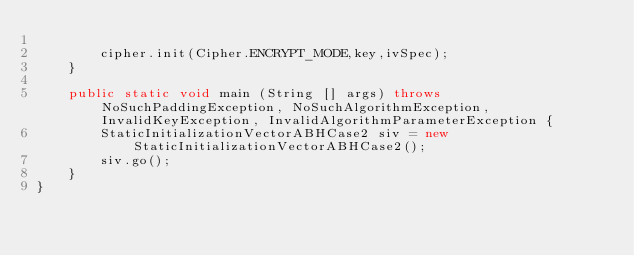<code> <loc_0><loc_0><loc_500><loc_500><_Java_>
        cipher.init(Cipher.ENCRYPT_MODE,key,ivSpec);
    }

    public static void main (String [] args) throws NoSuchPaddingException, NoSuchAlgorithmException, InvalidKeyException, InvalidAlgorithmParameterException {
        StaticInitializationVectorABHCase2 siv = new StaticInitializationVectorABHCase2();
        siv.go();
    }
}
</code> 